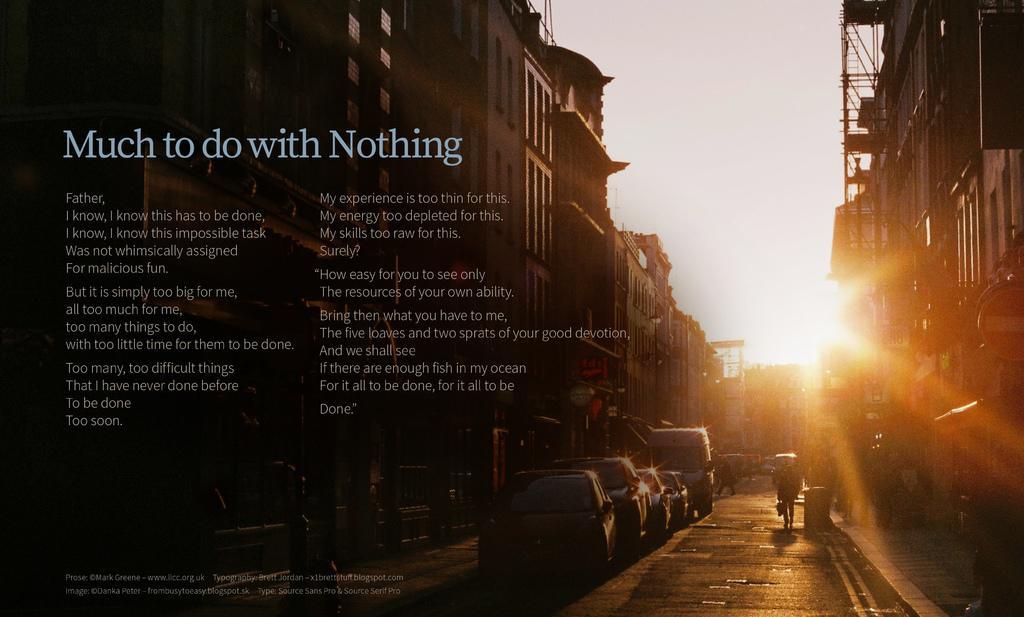Please provide a concise description of this image. In the picture I can see buildings, vehicles and people. In the background I can see the sky and the sun. I can also see something written on the image. 